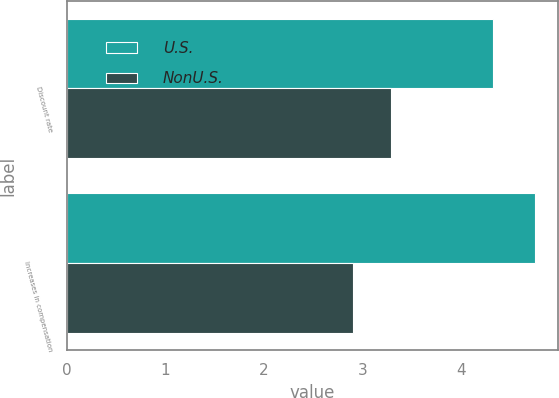<chart> <loc_0><loc_0><loc_500><loc_500><stacked_bar_chart><ecel><fcel>Discount rate<fcel>Increases in compensation<nl><fcel>U.S.<fcel>4.33<fcel>4.75<nl><fcel>NonU.S.<fcel>3.29<fcel>2.91<nl></chart> 